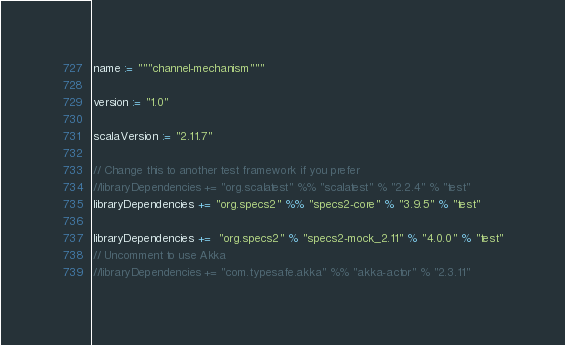Convert code to text. <code><loc_0><loc_0><loc_500><loc_500><_Scala_>name := """channel-mechanism"""

version := "1.0"

scalaVersion := "2.11.7"

// Change this to another test framework if you prefer
//libraryDependencies += "org.scalatest" %% "scalatest" % "2.2.4" % "test"
libraryDependencies += "org.specs2" %% "specs2-core" % "3.9.5" % "test"

libraryDependencies +=  "org.specs2" % "specs2-mock_2.11" % "4.0.0" % "test"
// Uncomment to use Akka
//libraryDependencies += "com.typesafe.akka" %% "akka-actor" % "2.3.11"


</code> 